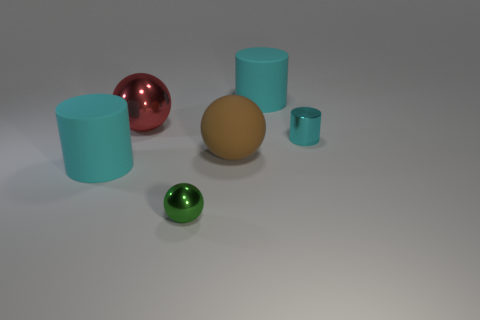Add 4 green metal objects. How many objects exist? 10 Add 3 big brown matte balls. How many big brown matte balls are left? 4 Add 2 tiny cyan metal things. How many tiny cyan metal things exist? 3 Subtract 0 brown cubes. How many objects are left? 6 Subtract all big brown rubber balls. Subtract all tiny green metal cubes. How many objects are left? 5 